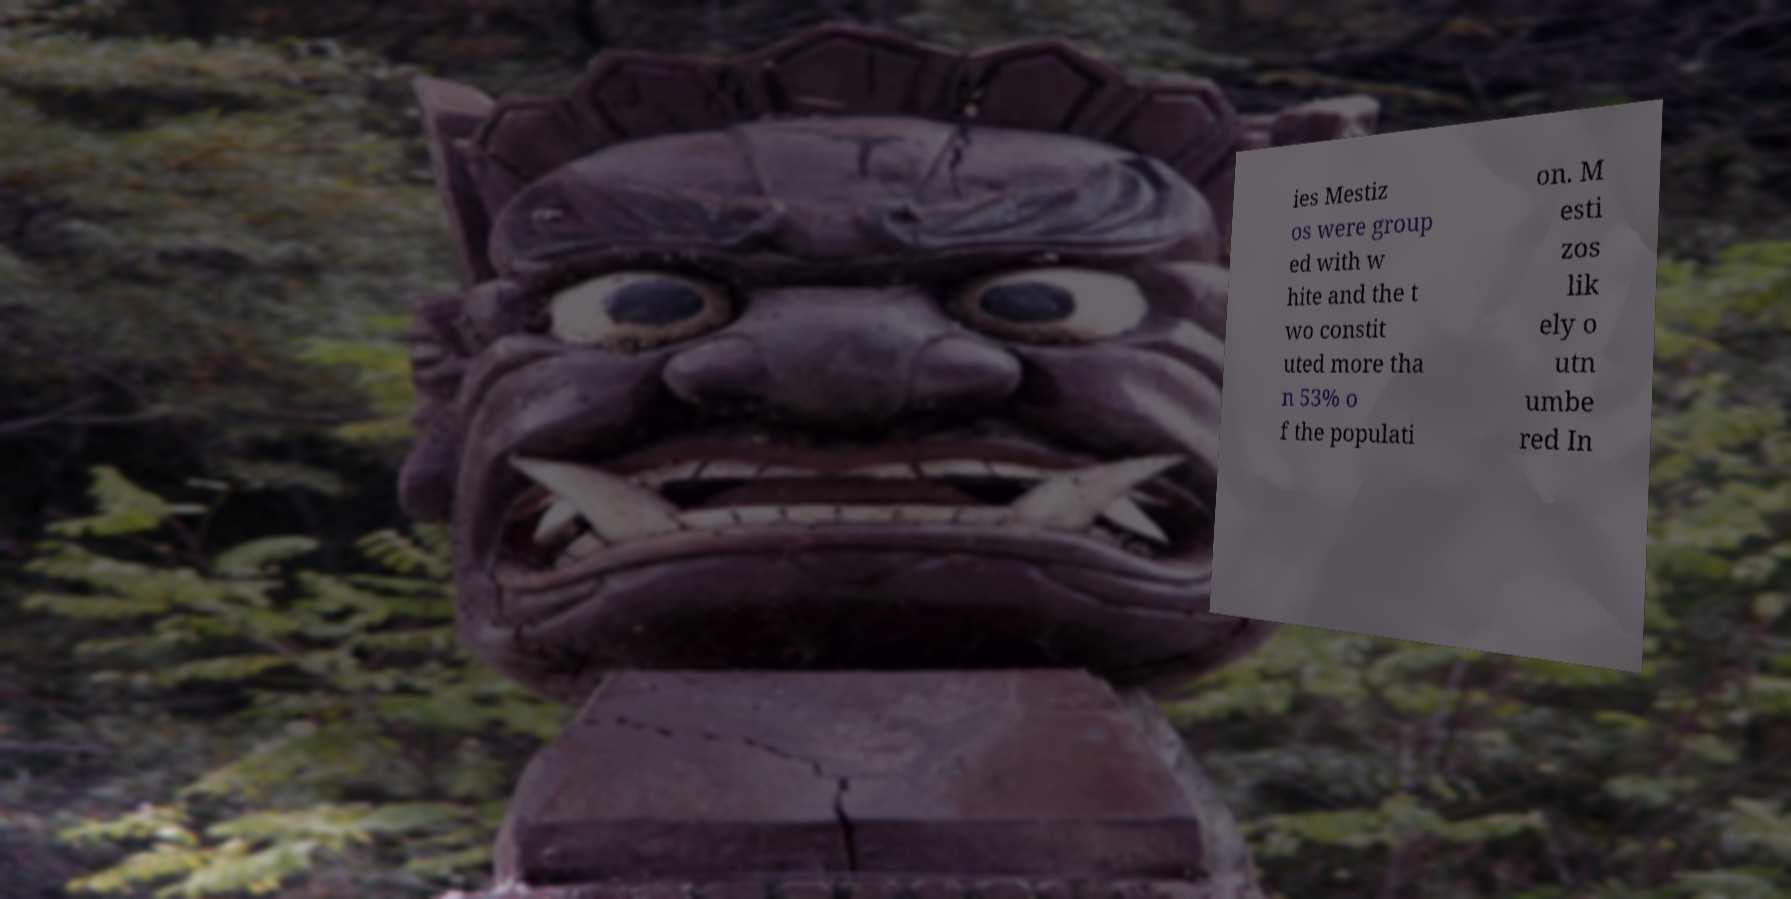Could you extract and type out the text from this image? ies Mestiz os were group ed with w hite and the t wo constit uted more tha n 53% o f the populati on. M esti zos lik ely o utn umbe red In 